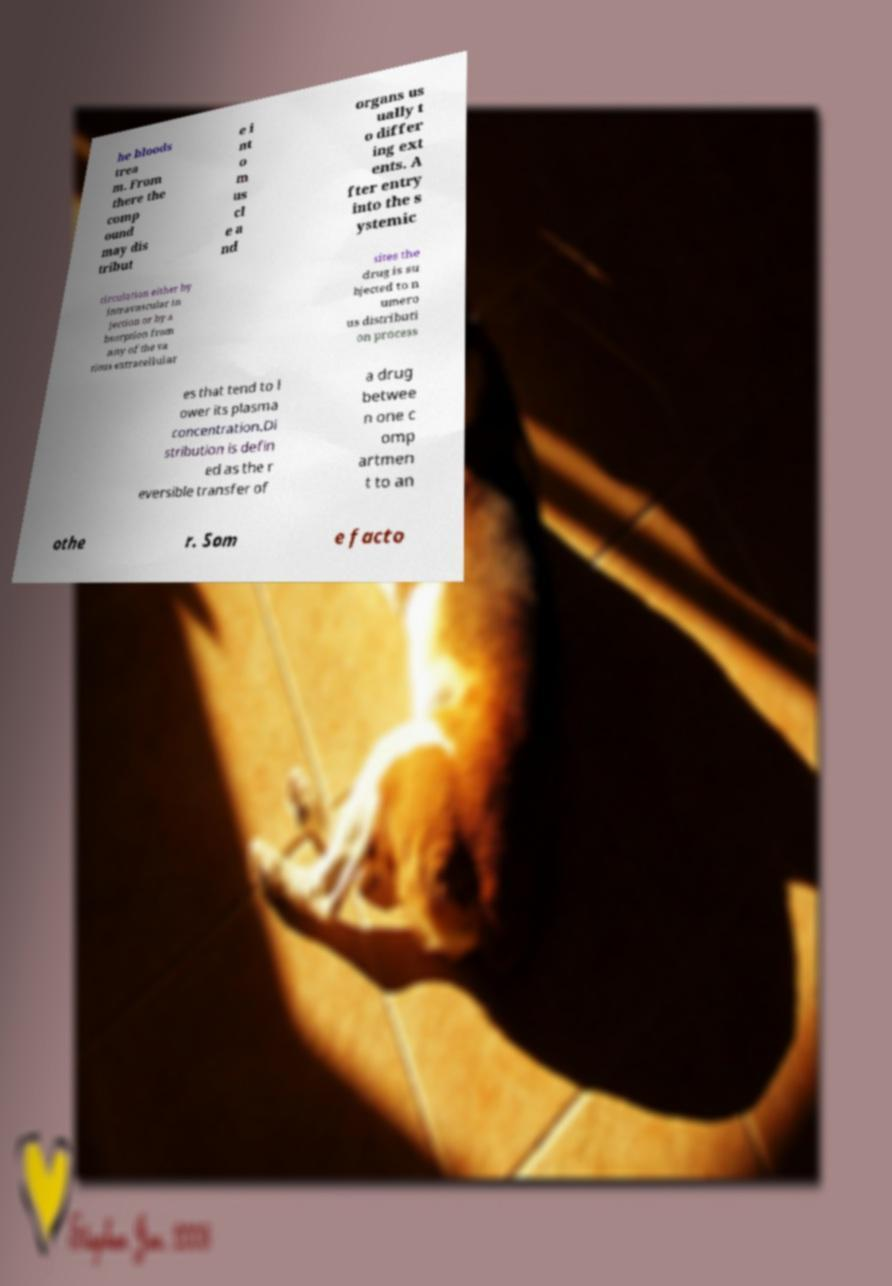Please read and relay the text visible in this image. What does it say? he bloods trea m. From there the comp ound may dis tribut e i nt o m us cl e a nd organs us ually t o differ ing ext ents. A fter entry into the s ystemic circulation either by intravascular in jection or by a bsorption from any of the va rious extracellular sites the drug is su bjected to n umero us distributi on process es that tend to l ower its plasma concentration.Di stribution is defin ed as the r eversible transfer of a drug betwee n one c omp artmen t to an othe r. Som e facto 